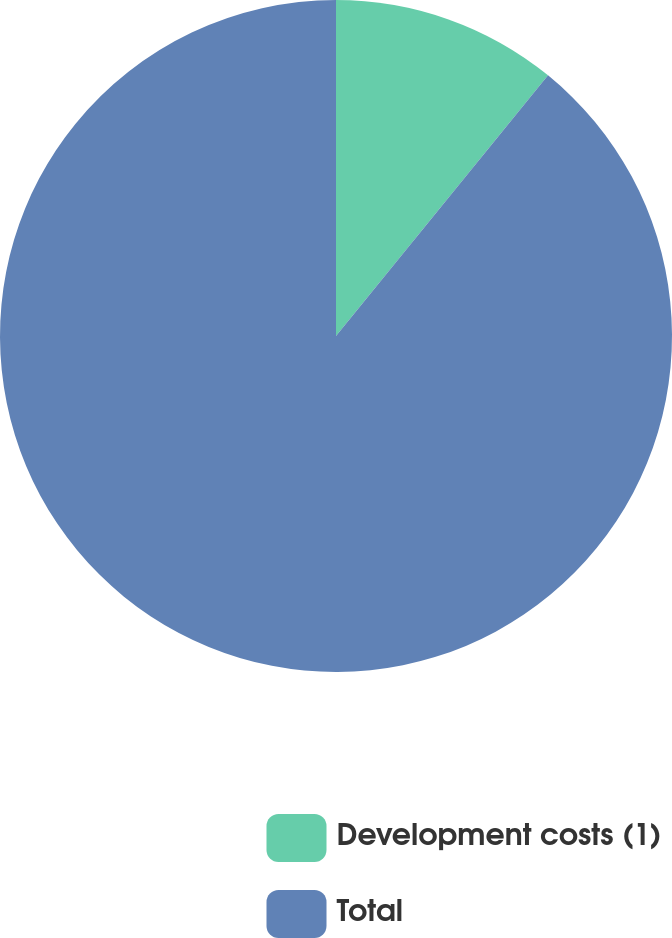Convert chart. <chart><loc_0><loc_0><loc_500><loc_500><pie_chart><fcel>Development costs (1)<fcel>Total<nl><fcel>10.87%<fcel>89.13%<nl></chart> 